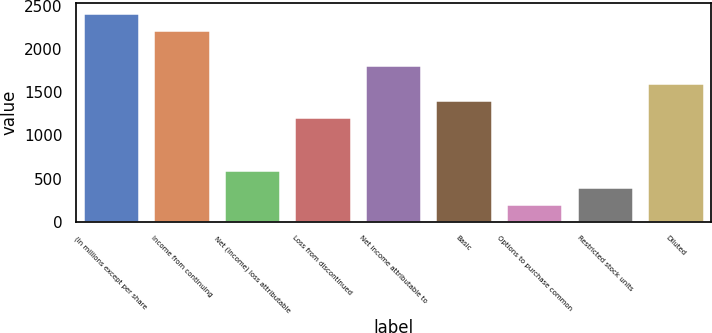Convert chart. <chart><loc_0><loc_0><loc_500><loc_500><bar_chart><fcel>(In millions except per share<fcel>Income from continuing<fcel>Net (income) loss attributable<fcel>Loss from discontinued<fcel>Net income attributable to<fcel>Basic<fcel>Options to purchase common<fcel>Restricted stock units<fcel>Diluted<nl><fcel>2416.63<fcel>2215.3<fcel>604.66<fcel>1208.65<fcel>1812.64<fcel>1409.98<fcel>202<fcel>403.33<fcel>1611.31<nl></chart> 